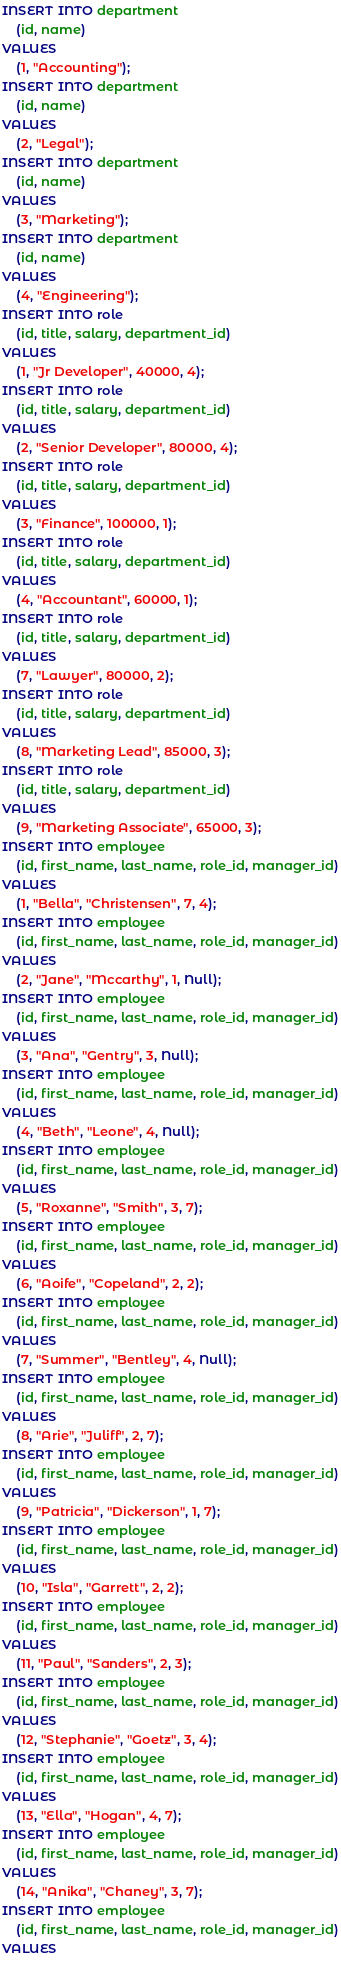<code> <loc_0><loc_0><loc_500><loc_500><_SQL_>INSERT INTO department
    (id, name)
VALUES
    (1, "Accounting");
INSERT INTO department
    (id, name)
VALUES
    (2, "Legal");
INSERT INTO department
    (id, name)
VALUES
    (3, "Marketing");
INSERT INTO department
    (id, name)
VALUES
    (4, "Engineering");
INSERT INTO role
    (id, title, salary, department_id)
VALUES
    (1, "Jr Developer", 40000, 4);
INSERT INTO role
    (id, title, salary, department_id)
VALUES
    (2, "Senior Developer", 80000, 4);
INSERT INTO role
    (id, title, salary, department_id)
VALUES
    (3, "Finance", 100000, 1);
INSERT INTO role
    (id, title, salary, department_id)
VALUES
    (4, "Accountant", 60000, 1);
INSERT INTO role
    (id, title, salary, department_id)
VALUES
    (7, "Lawyer", 80000, 2);
INSERT INTO role
    (id, title, salary, department_id)
VALUES
    (8, "Marketing Lead", 85000, 3);
INSERT INTO role
    (id, title, salary, department_id)
VALUES
    (9, "Marketing Associate", 65000, 3);
INSERT INTO employee
    (id, first_name, last_name, role_id, manager_id)
VALUES
    (1, "Bella", "Christensen", 7, 4);
INSERT INTO employee
    (id, first_name, last_name, role_id, manager_id)
VALUES
    (2, "Jane", "Mccarthy", 1, Null);
INSERT INTO employee
    (id, first_name, last_name, role_id, manager_id)
VALUES
    (3, "Ana", "Gentry", 3, Null);
INSERT INTO employee
    (id, first_name, last_name, role_id, manager_id)
VALUES
    (4, "Beth", "Leone", 4, Null);
INSERT INTO employee
    (id, first_name, last_name, role_id, manager_id)
VALUES
    (5, "Roxanne", "Smith", 3, 7);
INSERT INTO employee
    (id, first_name, last_name, role_id, manager_id)
VALUES
    (6, "Aoife", "Copeland", 2, 2);
INSERT INTO employee
    (id, first_name, last_name, role_id, manager_id)
VALUES
    (7, "Summer", "Bentley", 4, Null);
INSERT INTO employee
    (id, first_name, last_name, role_id, manager_id)
VALUES
    (8, "Arie", "Juliff", 2, 7);
INSERT INTO employee
    (id, first_name, last_name, role_id, manager_id)
VALUES
    (9, "Patricia", "Dickerson", 1, 7);
INSERT INTO employee
    (id, first_name, last_name, role_id, manager_id)
VALUES
    (10, "Isla", "Garrett", 2, 2);
INSERT INTO employee
    (id, first_name, last_name, role_id, manager_id)
VALUES
    (11, "Paul", "Sanders", 2, 3);
INSERT INTO employee
    (id, first_name, last_name, role_id, manager_id)
VALUES
    (12, "Stephanie", "Goetz", 3, 4);
INSERT INTO employee
    (id, first_name, last_name, role_id, manager_id)
VALUES
    (13, "Ella", "Hogan", 4, 7);
INSERT INTO employee
    (id, first_name, last_name, role_id, manager_id)
VALUES
    (14, "Anika", "Chaney", 3, 7);
INSERT INTO employee
    (id, first_name, last_name, role_id, manager_id)
VALUES</code> 